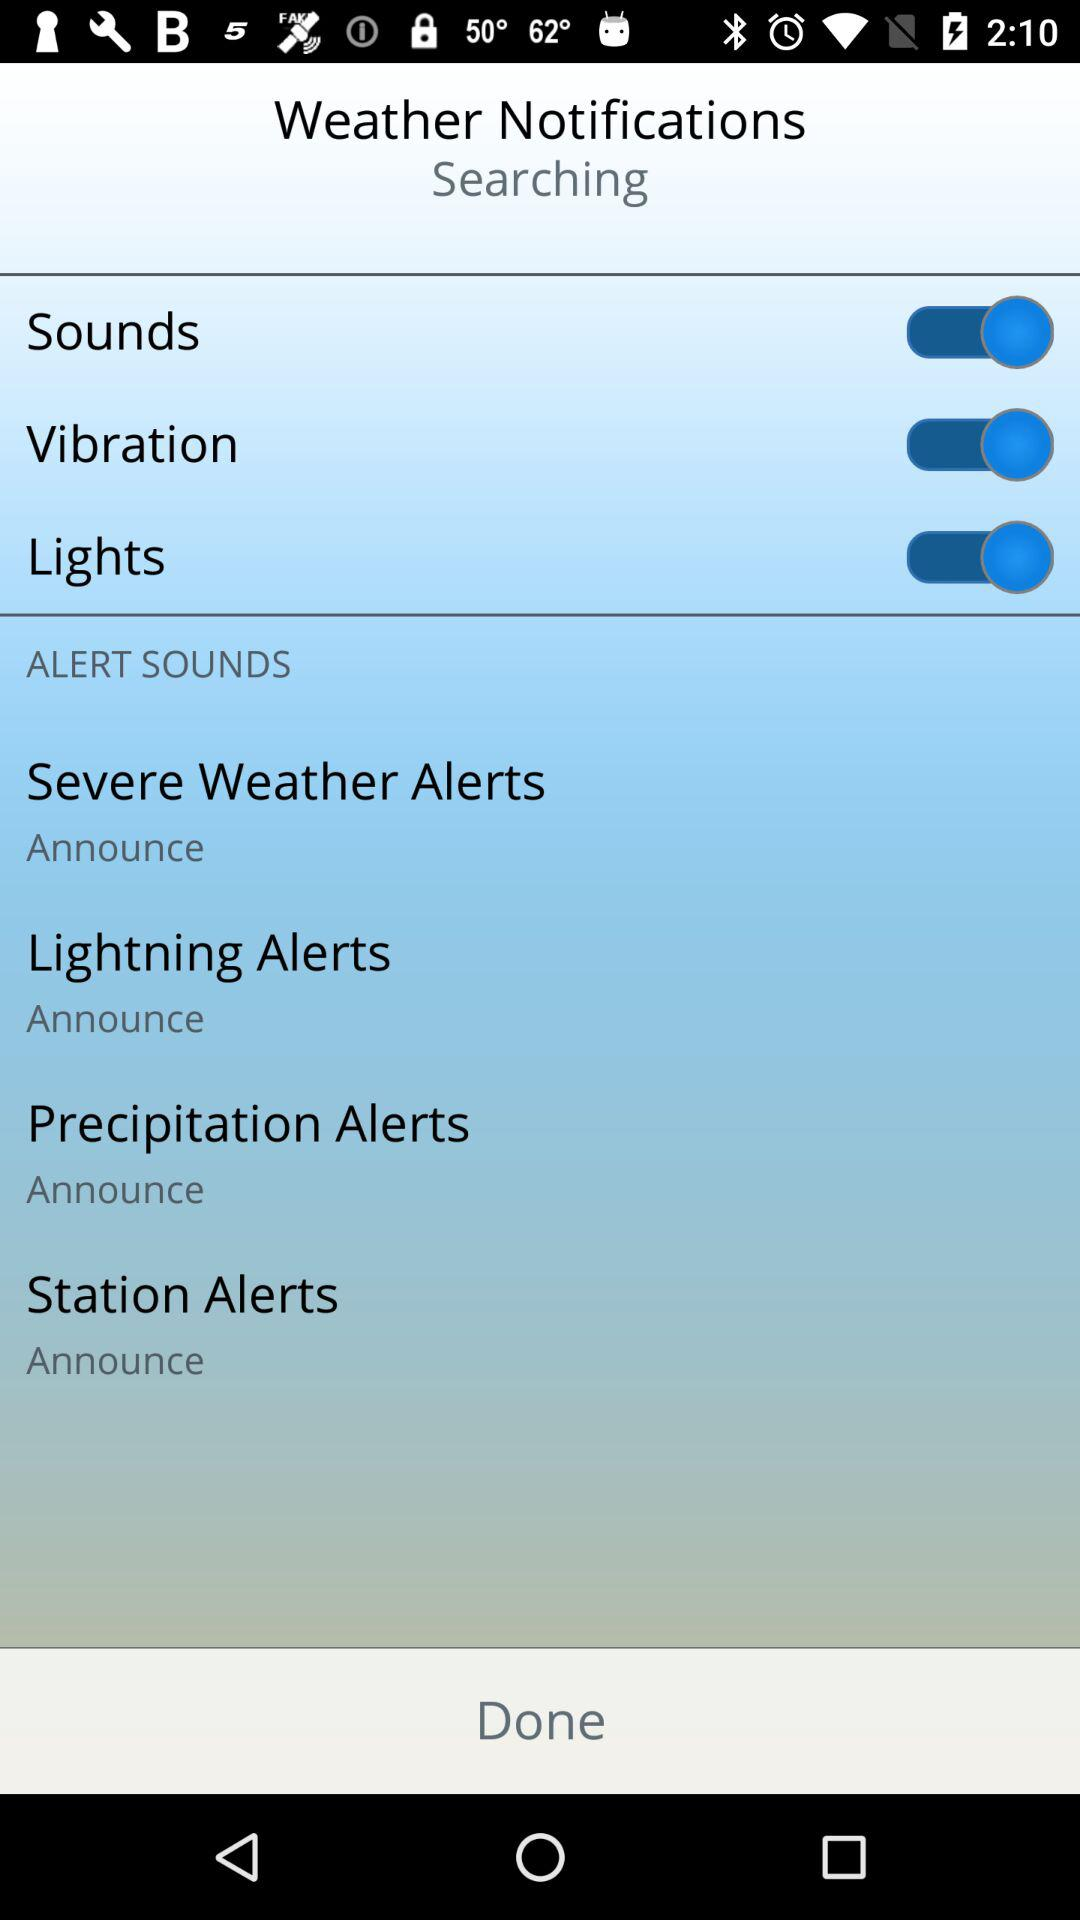What is the setting for the station alerts in "ALERT SOUNDS"? The setting for the station alerts is "Announce". 